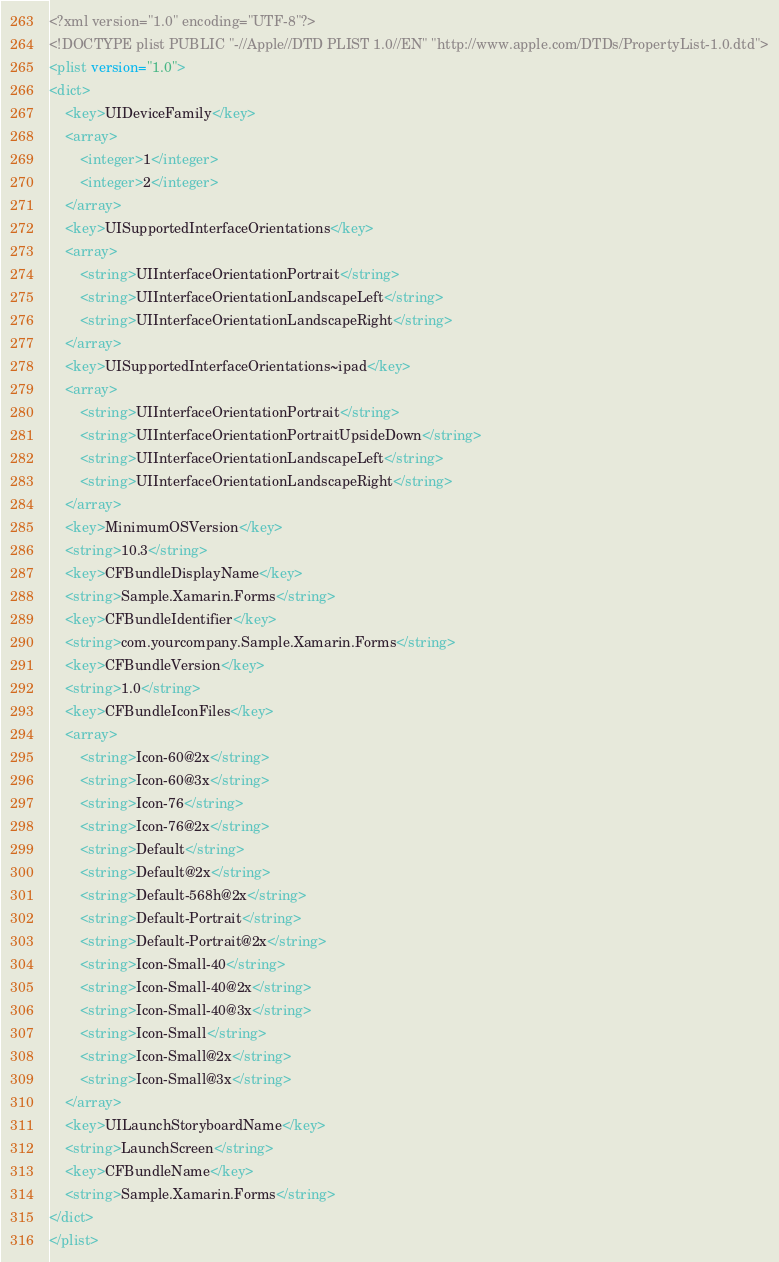<code> <loc_0><loc_0><loc_500><loc_500><_XML_><?xml version="1.0" encoding="UTF-8"?>
<!DOCTYPE plist PUBLIC "-//Apple//DTD PLIST 1.0//EN" "http://www.apple.com/DTDs/PropertyList-1.0.dtd">
<plist version="1.0">
<dict>
	<key>UIDeviceFamily</key>
	<array>
		<integer>1</integer>
		<integer>2</integer>
	</array>
	<key>UISupportedInterfaceOrientations</key>
	<array>
		<string>UIInterfaceOrientationPortrait</string>
		<string>UIInterfaceOrientationLandscapeLeft</string>
		<string>UIInterfaceOrientationLandscapeRight</string>
	</array>
	<key>UISupportedInterfaceOrientations~ipad</key>
	<array>
		<string>UIInterfaceOrientationPortrait</string>
		<string>UIInterfaceOrientationPortraitUpsideDown</string>
		<string>UIInterfaceOrientationLandscapeLeft</string>
		<string>UIInterfaceOrientationLandscapeRight</string>
	</array>
	<key>MinimumOSVersion</key>
	<string>10.3</string>
	<key>CFBundleDisplayName</key>
	<string>Sample.Xamarin.Forms</string>
	<key>CFBundleIdentifier</key>
	<string>com.yourcompany.Sample.Xamarin.Forms</string>
	<key>CFBundleVersion</key>
	<string>1.0</string>
	<key>CFBundleIconFiles</key>
	<array>
		<string>Icon-60@2x</string>
		<string>Icon-60@3x</string>
		<string>Icon-76</string>
		<string>Icon-76@2x</string>
		<string>Default</string>
		<string>Default@2x</string>
		<string>Default-568h@2x</string>
		<string>Default-Portrait</string>
		<string>Default-Portrait@2x</string>
		<string>Icon-Small-40</string>
		<string>Icon-Small-40@2x</string>
		<string>Icon-Small-40@3x</string>
		<string>Icon-Small</string>
		<string>Icon-Small@2x</string>
		<string>Icon-Small@3x</string>
	</array>
	<key>UILaunchStoryboardName</key>
	<string>LaunchScreen</string>
	<key>CFBundleName</key>
	<string>Sample.Xamarin.Forms</string>
</dict>
</plist>
</code> 